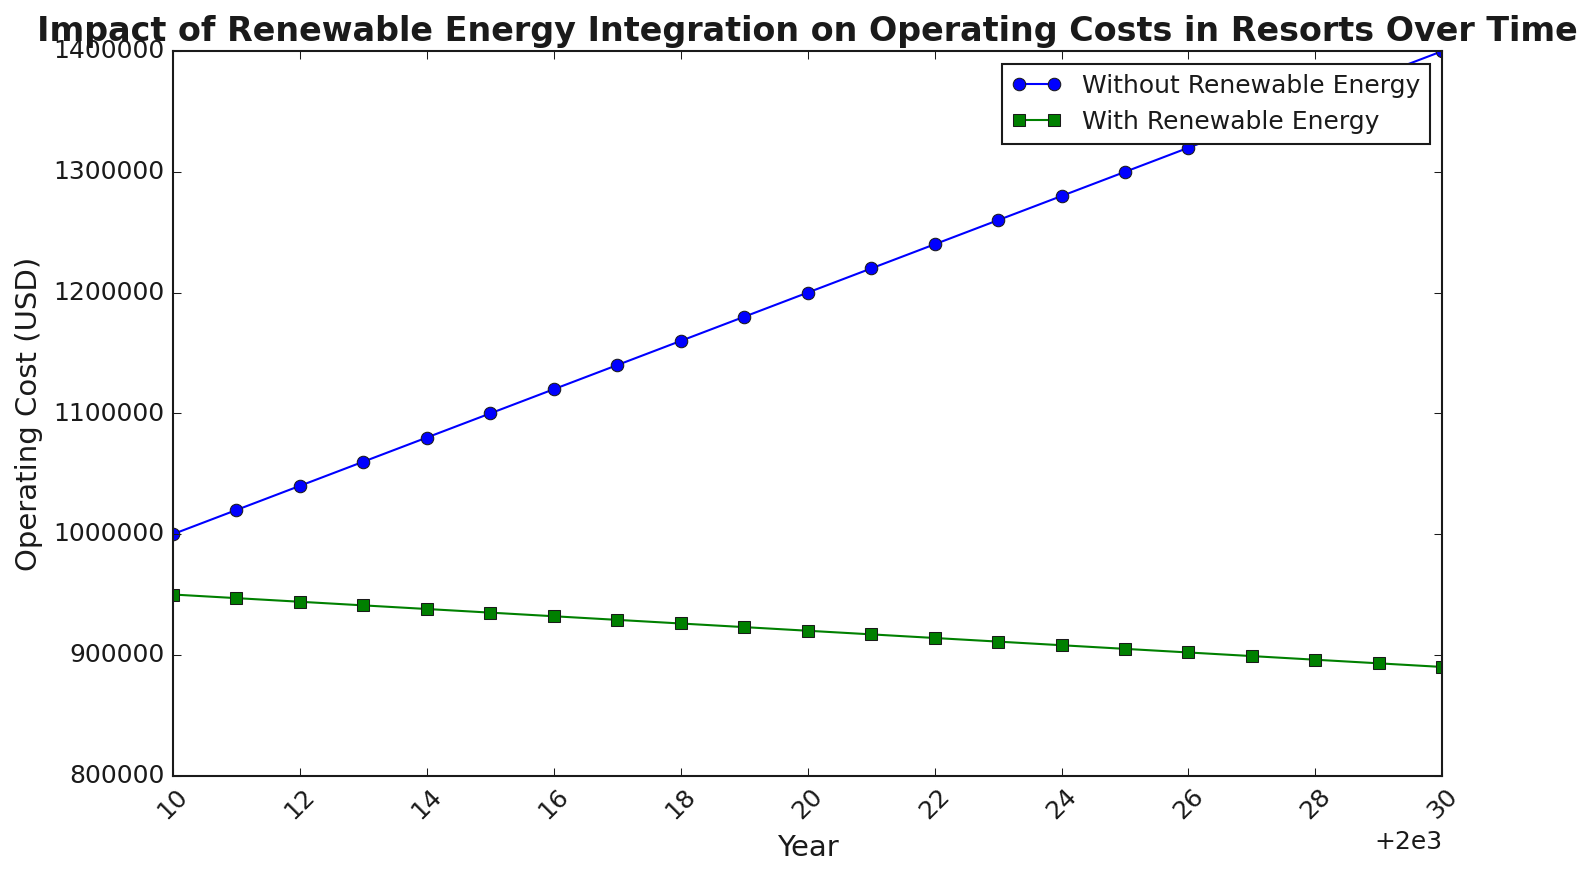What is the trend of operating costs for resorts without renewable energy from 2010 to 2030? The blue line representing operating costs without renewable energy shows a continuous increase from $1,000,000 in 2010 to $1,400,000 in 2030. This is a clear upward trend indicating rising costs over time.
Answer: Continual increase What is the difference in operating costs between the years 2010 and 2030 for resorts using renewable energy? The operating cost for resorts with renewable energy in 2010 is $950,000 and in 2030 is $890,000. The difference is $950,000 - $890,000 = $60,000.
Answer: $60,000 In which year is the operating cost difference between the two methods the highest? By observing the gap between the blue and green lines, the difference is highest in the year 2030. The costs are $1,400,000 (without renewable) and $890,000 (with renewable), resulting in a difference of $510,000.
Answer: 2030 Which method shows a lower operating cost in 2020, and by how much? In 2020, the operating cost without renewable energy is $1,200,000 and with renewable energy is $920,000. The cost with renewable energy is lower by $1,200,000 - $920,000 = $280,000.
Answer: With renewable energy by $280,000 On average, how much do the operating costs decrease annually for resorts using renewable energy? From 2010 to 2030, the costs decrease from $950,000 to $890,000. The total decrease over 20 years is $950,000 - $890,000 = $60,000. Annually, the average decrease is $60,000 / 20 = $3,000.
Answer: $3,000 per year In which year do the operating costs with renewable energy reach exactly $900,000? By examining the green line, the costs reach $900,000 in the year 2028.
Answer: 2028 How much did the operating costs without renewable energy increase between 2015 and 2020? In 2015, the operating costs without renewable energy are $1,100,000 and in 2020 they are $1,200,000. The increase is $1,200,000 - $1,100,000 = $100,000.
Answer: $100,000 Compare the slopes of the two trend lines. Which one is steeper, and what does it imply? The slope of the line without renewable energy (blue line) is steeper compared to the line with renewable energy (green line). This implies that the costs are increasing at a faster rate for resorts without renewable energy.
Answer: Without renewable energy is steeper What is the average operating cost for both methods over the period 2010-2030? For without renewable energy: Sum from 2010 to 2030 = $1,000,000 + ... + $1,400,000 = $27,000,000. Average = $27,000,000 / 21 = $1,285,714. For with renewable energy: Sum from 2010 to 2030 = $950,000 + ... + $890,000 = $19,155,000. Average = $19,155,000 / 21 = $912,143.
Answer: $1,285,714 (without), $912,143 (with) What visual difference can be observed between the lines representing operating costs with and without renewable energy? The blue line representing operating costs without renewable energy is above the green line throughout the period, showing generally higher costs, and has a steeper positive slope compared to the more gradually decreasing green line representing operating costs with renewable energy.
Answer: Blue line is higher and steeper than the green line 